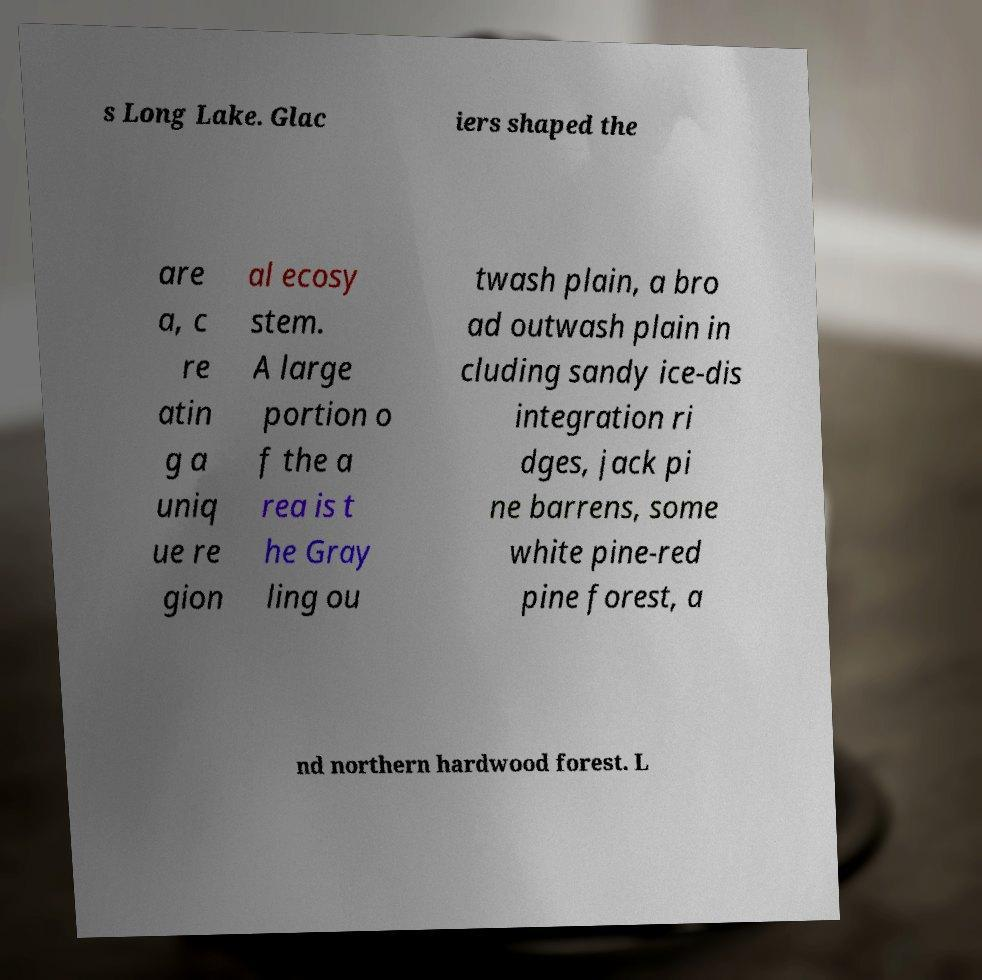Please read and relay the text visible in this image. What does it say? s Long Lake. Glac iers shaped the are a, c re atin g a uniq ue re gion al ecosy stem. A large portion o f the a rea is t he Gray ling ou twash plain, a bro ad outwash plain in cluding sandy ice-dis integration ri dges, jack pi ne barrens, some white pine-red pine forest, a nd northern hardwood forest. L 